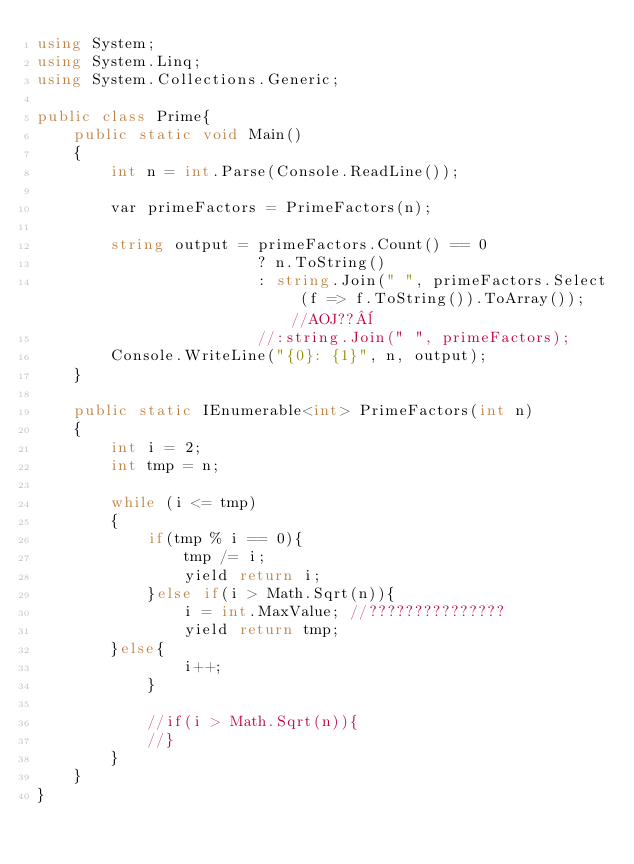Convert code to text. <code><loc_0><loc_0><loc_500><loc_500><_C#_>using System;
using System.Linq;
using System.Collections.Generic;

public class Prime{
    public static void Main()
    {
        int n = int.Parse(Console.ReadLine());
         
        var primeFactors = PrimeFactors(n);
         
        string output = primeFactors.Count() == 0 
                        ? n.ToString() 
                        : string.Join(" ", primeFactors.Select (f => f.ToString()).ToArray()); //AOJ??¨
                        //:string.Join(" ", primeFactors);
        Console.WriteLine("{0}: {1}", n, output);
    }
     
    public static IEnumerable<int> PrimeFactors(int n)
    {
        int i = 2;
        int tmp = n;
         
        while (i <= tmp)
        {
            if(tmp % i == 0){
                tmp /= i;
                yield return i;
            }else if(i > Math.Sqrt(n)){
                i = int.MaxValue; //???????????????
                yield return tmp;
	    }else{
                i++;
            }
             
            //if(i > Math.Sqrt(n)){
            //}
        }
    }
}</code> 